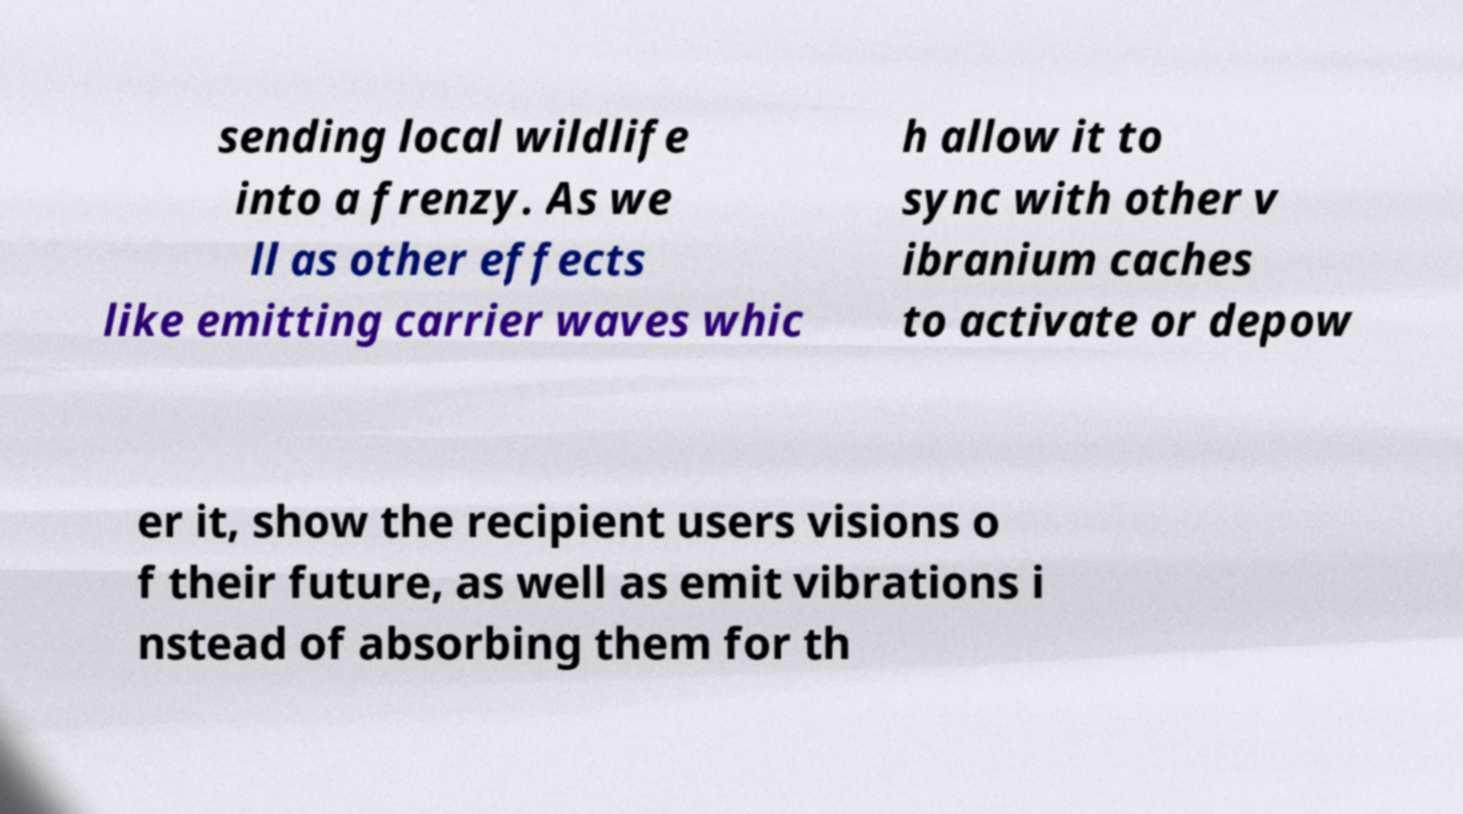Please identify and transcribe the text found in this image. sending local wildlife into a frenzy. As we ll as other effects like emitting carrier waves whic h allow it to sync with other v ibranium caches to activate or depow er it, show the recipient users visions o f their future, as well as emit vibrations i nstead of absorbing them for th 